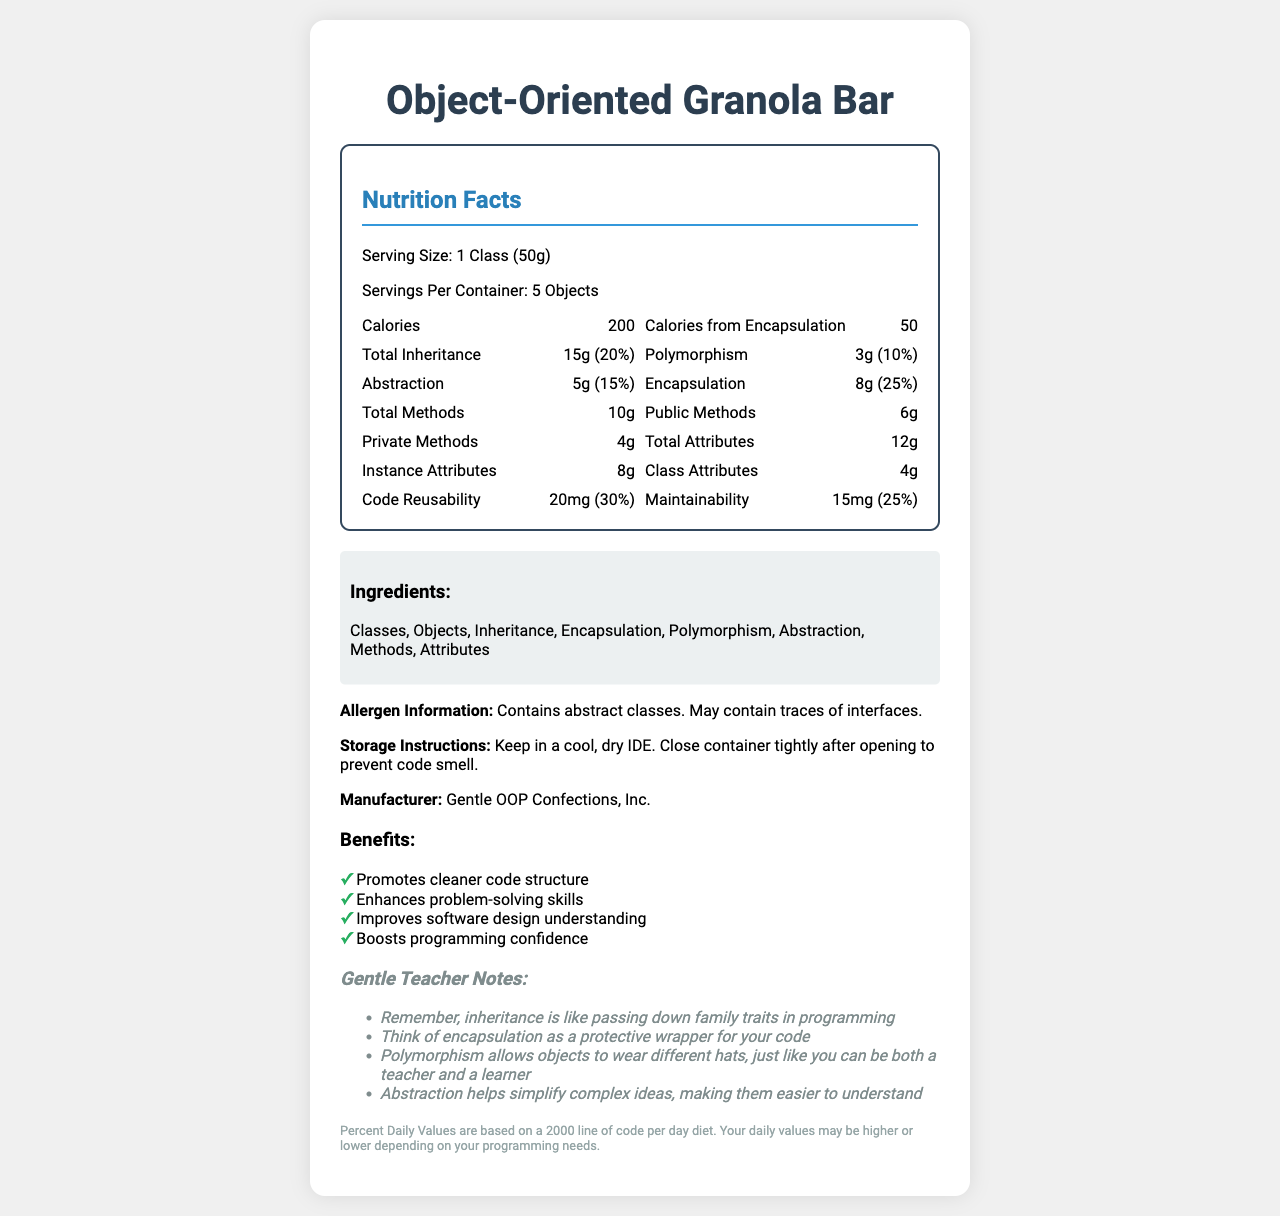what is the serving size of the Object-Oriented Granola Bar? The serving size is clearly listed as "1 Class (50g)" under the Nutrition Facts heading.
Answer: 1 Class (50g) how many servings are in one container? The document specifies that there are "5 Objects" per container under the Nutrition Facts heading.
Answer: 5 Objects what are the calories in one serving? The document lists "Calories" as 200 under the Nutrition Facts heading.
Answer: 200 how much abstraction is in one serving? Under the Nutrition Facts section, the amount of Abstraction per serving is listed as 5g.
Answer: 5g what percentage of daily value does the encapsulation provide? Encapsulation's Percent Daily Value is given as 25% under the Nutrition Facts section.
Answer: 25% which of the following ingredients are in the Object-Oriented Granola Bar? A. Arrays B. Methods C. Loops D. Classes The ingredients listed in the document include both "Methods" and "Classes."
Answer: B, D what is the caloric benefit from encapsulation? The document lists "Calories from Encapsulation" as 50 under the Nutrition Facts.
Answer: 50 calories what company manufactures the Object-Oriented Granola Bar? The Manufacturer section states the product is made by "Gentle OOP Confections, Inc."
Answer: Gentle OOP Confections, Inc. is the product likely to contain interfaces as allergens? (yes/no) The Allergen Information section notes that the product "May contain traces of interfaces."
Answer: Yes which Nutrient contributes the most to the Percent Daily Value? A. Inheritance B. Encapsulation C. Polymorphism D. Abstraction E. Code Reusability The document states that Code Reusability provides a 30% Percent Daily Value, the highest among all listed nutrients.
Answer: E. Code Reusability describe the main purpose of this document The document serves as a creatively themed nutritional label for a granola bar, using Object-Oriented Programming (OOP) concepts as its main ingredients. It provides detailed information about serving sizes, nutritional benefits, and the positive effects of OOP principles on software development. It also includes clarifications and analogies from a gentle teacher aimed at making OOP easier to understand.
Answer: The document provides detailed nutritional information about the Object-Oriented Granola Bar, including its servings, calorie content, and the contributions of various OOP principles like inheritance, encapsulation, and polymorphism. It also mentions the benefits, manufacturer, and allergen warnings, and includes notes from a gentle teacher to help understand OOP concepts. what are the benefits of consuming the Object-Oriented Granola Bar, according to the document? The Benefits section lists these as the main advantages of using the product.
Answer: Promotes cleaner code structure, Enhances problem-solving skills, Improves software design understanding, Boosts programming confidence can I find the ingredients section on the label? The document has a section dedicated to listing the ingredients which include Classes, Objects, Inheritance, Encapsulation, Polymorphism, Abstraction, Methods, Attributes.
Answer: Yes what instructions are given for storing the Object-Oriented Granola Bar? The Storage Instructions section provides these specific guidelines for storing the product.
Answer: Keep in a cool, dry IDE. Close container tightly after opening to prevent code smell. what is the amount of maintainability per serving? Under the Nutrition Facts, the amount of Maintainability per serving is listed as 15mg.
Answer: 15mg How is polymorphism explained in the gentle teacher notes? The Gentle Teacher Notes section gives this analogy to explain polymorphism.
Answer: Polymorphism allows objects to wear different hats, just like you can be both a teacher and a learner is there information about the expiration date of the Object-Oriented Granola Bar? The provided document does not mention anything about an expiration date.
Answer: Not enough information what attribute types are mentioned under the Nutrition Facts? The document lists "Instance" and "Class" as types of Attributes under the Nutrition Facts.
Answer: Instance, Class 